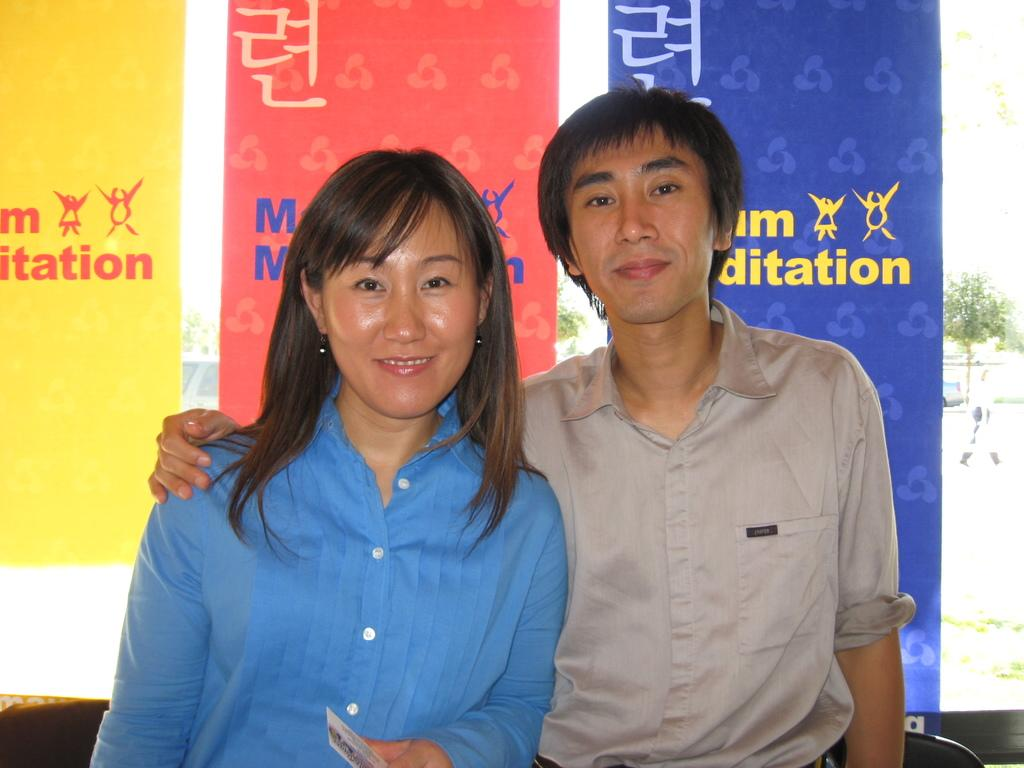How many people are in the image? There are two people in the image, a man and a woman. What are the man and the woman doing in the image? Both the man and the woman are standing and smiling. What can be seen in the backdrop of the image? There are banners and a plant in the backdrop of the image. What type of plough is being used on the sidewalk in the image? There is no plough or sidewalk present in the image. 